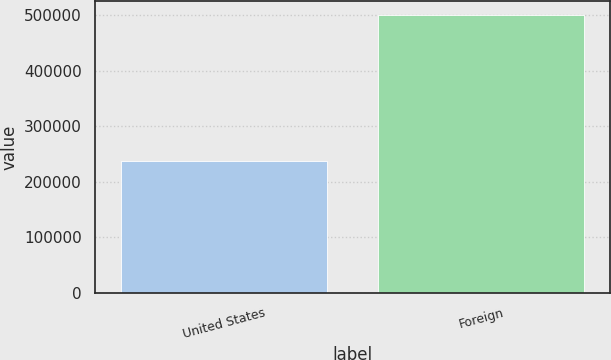Convert chart. <chart><loc_0><loc_0><loc_500><loc_500><bar_chart><fcel>United States<fcel>Foreign<nl><fcel>236932<fcel>499757<nl></chart> 